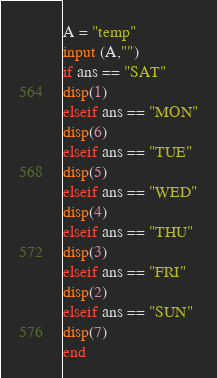<code> <loc_0><loc_0><loc_500><loc_500><_Octave_>A = "temp"
input (A,"")
if ans == "SAT" 
disp(1)
elseif ans == "MON"
disp(6)
elseif ans == "TUE"
disp(5)
elseif ans == "WED"
disp(4)
elseif ans == "THU"
disp(3)
elseif ans == "FRI"
disp(2)
elseif ans == "SUN"
disp(7)
end
</code> 